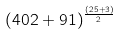Convert formula to latex. <formula><loc_0><loc_0><loc_500><loc_500>( 4 0 2 + 9 1 ) ^ { \frac { ( 2 5 + 3 ) } { 2 } }</formula> 